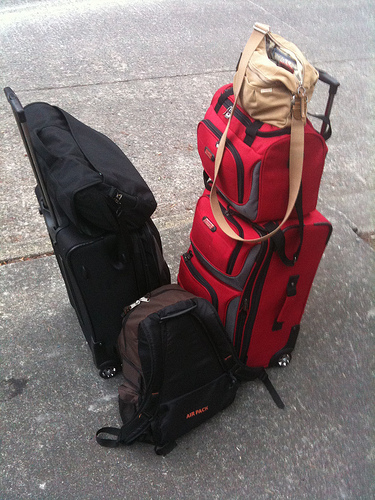Describe the style and potential use of the various luggage pieces captured in the image. The image displays a diverse array of luggage types, including a rolling black suitcase, ideal for smooth transport during travel, a large red suitcase likely for heavy packing needs, a backpack suitable for trekking or short trips, and a small casual purse for personal items or day use. 